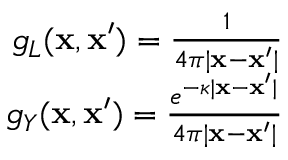<formula> <loc_0><loc_0><loc_500><loc_500>\begin{array} { r } { g _ { L } ( x , x ^ { \prime } ) = \frac { 1 } { 4 \pi | x - x ^ { \prime } | } } \\ { g _ { Y } ( x , x ^ { \prime } ) = \frac { e ^ { - \kappa | x - x ^ { \prime } | } } { 4 \pi | x - x ^ { \prime } | } } \end{array}</formula> 